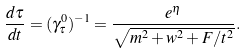Convert formula to latex. <formula><loc_0><loc_0><loc_500><loc_500>\frac { d \tau } { d t } = ( \gamma ^ { 0 } _ { \tau } ) ^ { - 1 } = \frac { e ^ { \eta } } { \sqrt { m ^ { 2 } + w ^ { 2 } + F / t ^ { 2 } } } .</formula> 